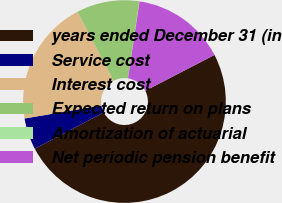Convert chart. <chart><loc_0><loc_0><loc_500><loc_500><pie_chart><fcel>years ended December 31 (in<fcel>Service cost<fcel>Interest cost<fcel>Expected return on plans<fcel>Amortization of actuarial<fcel>Net periodic pension benefit<nl><fcel>49.9%<fcel>5.03%<fcel>19.99%<fcel>10.02%<fcel>0.05%<fcel>15.0%<nl></chart> 